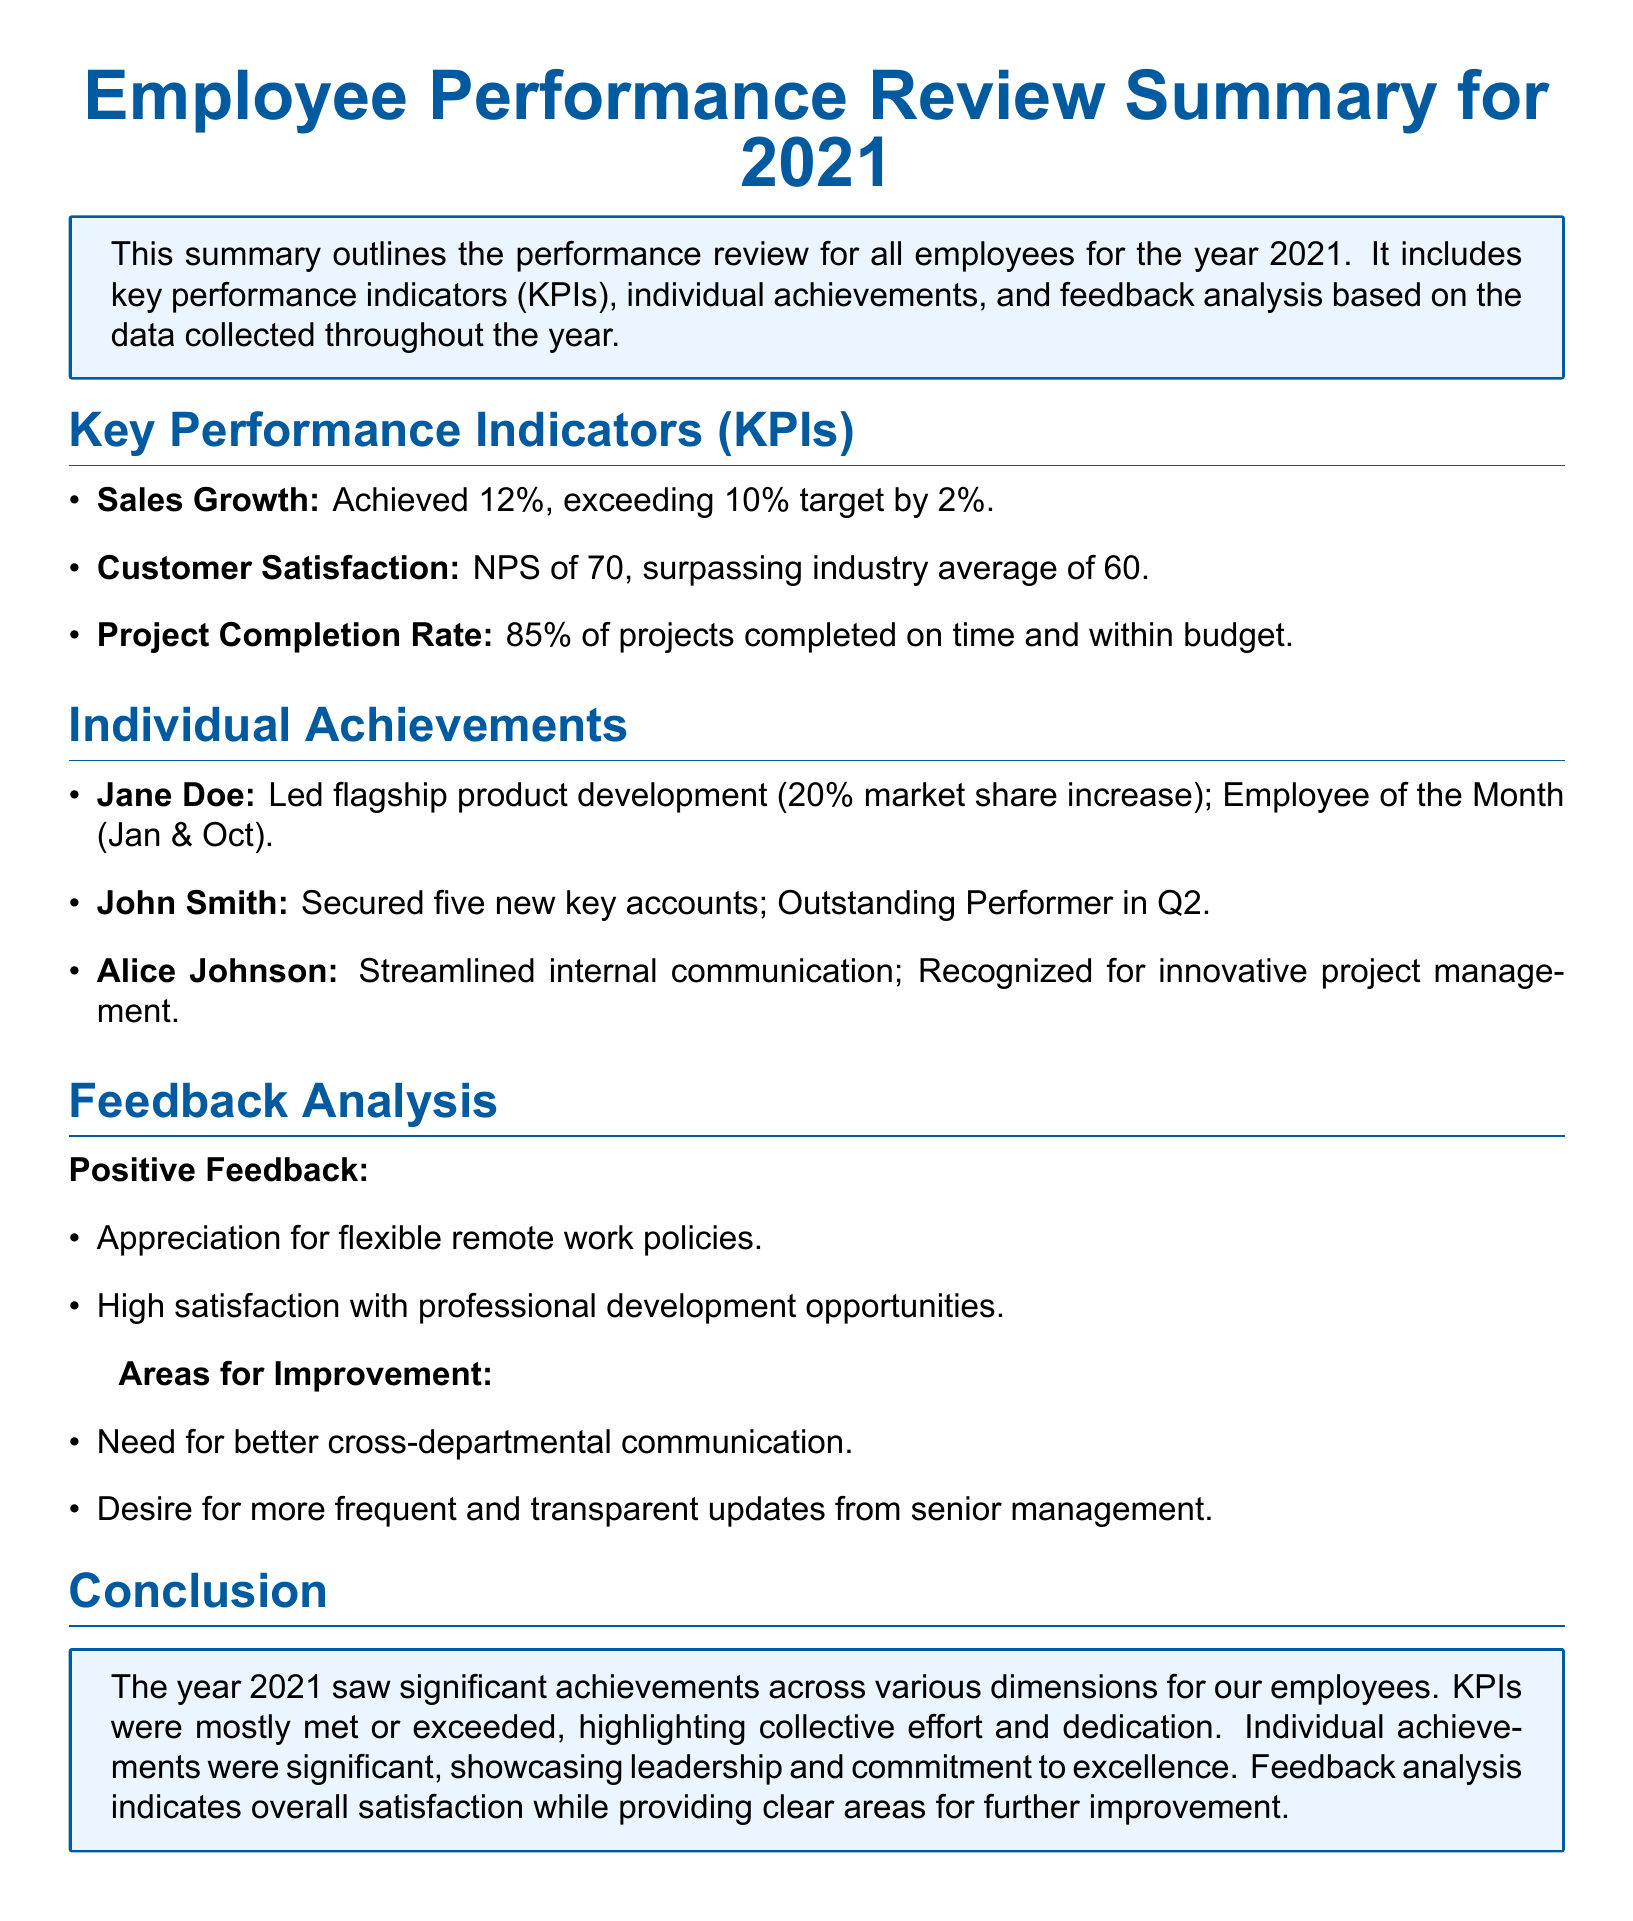What was the sales growth percentage in 2021? The sales growth is listed under Key Performance Indicators as achieving 12%.
Answer: 12% Who was recognized as Employee of the Month in January? The document states that Jane Doe was awarded Employee of the Month in January.
Answer: Jane Doe What was the Net Promoter Score (NPS) for customer satisfaction? The NPS is specifically mentioned in the KPIs section as 70.
Answer: 70 How many new key accounts did John Smith secure? The document indicates that John Smith secured five new key accounts.
Answer: five What is one area identified for improvement in feedback analysis? The document lists areas for improvement, one of which is better cross-departmental communication.
Answer: Better cross-departmental communication Which employee led the flagship product development? The document states that Jane Doe led the flagship product development.
Answer: Jane Doe How many projects were completed on time and within budget? The completion rate is given as 85%.
Answer: 85% What was the industry average NPS mentioned in the document? The document mentions the industry average NPS as 60.
Answer: 60 What is one positive feedback mentioned in the analysis? Positive feedback includes appreciation for flexible remote work policies.
Answer: Appreciation for flexible remote work policies 